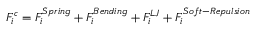<formula> <loc_0><loc_0><loc_500><loc_500>F _ { i } ^ { c } = F _ { i } ^ { S p r i n g } + F _ { i } ^ { B e n d i n g } + F _ { i } ^ { L J } + F _ { i } ^ { S o f t - R e p u l s i o n }</formula> 